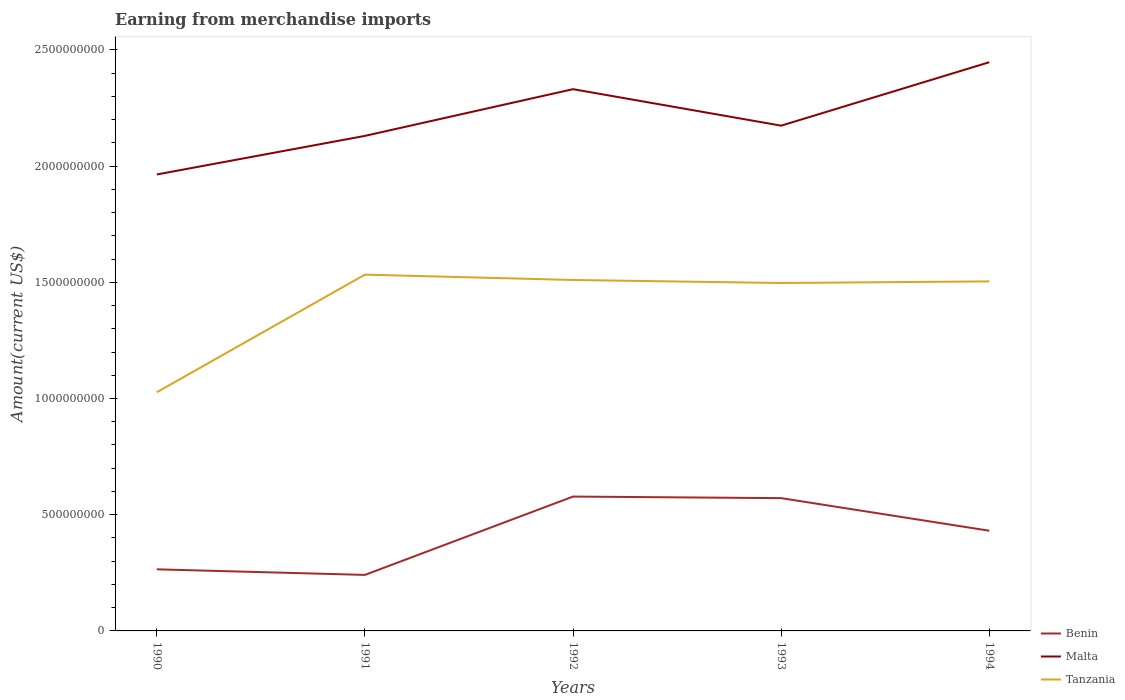How many different coloured lines are there?
Give a very brief answer. 3. Across all years, what is the maximum amount earned from merchandise imports in Benin?
Make the answer very short. 2.41e+08. What is the total amount earned from merchandise imports in Benin in the graph?
Offer a terse response. -3.30e+08. What is the difference between the highest and the second highest amount earned from merchandise imports in Tanzania?
Give a very brief answer. 5.06e+08. Is the amount earned from merchandise imports in Tanzania strictly greater than the amount earned from merchandise imports in Benin over the years?
Your answer should be compact. No. What is the difference between two consecutive major ticks on the Y-axis?
Give a very brief answer. 5.00e+08. Are the values on the major ticks of Y-axis written in scientific E-notation?
Offer a terse response. No. How many legend labels are there?
Make the answer very short. 3. How are the legend labels stacked?
Ensure brevity in your answer.  Vertical. What is the title of the graph?
Give a very brief answer. Earning from merchandise imports. Does "Mauritania" appear as one of the legend labels in the graph?
Your response must be concise. No. What is the label or title of the Y-axis?
Your answer should be very brief. Amount(current US$). What is the Amount(current US$) in Benin in 1990?
Make the answer very short. 2.65e+08. What is the Amount(current US$) in Malta in 1990?
Offer a terse response. 1.96e+09. What is the Amount(current US$) in Tanzania in 1990?
Your answer should be compact. 1.03e+09. What is the Amount(current US$) in Benin in 1991?
Your answer should be compact. 2.41e+08. What is the Amount(current US$) of Malta in 1991?
Your answer should be very brief. 2.13e+09. What is the Amount(current US$) in Tanzania in 1991?
Your answer should be compact. 1.53e+09. What is the Amount(current US$) in Benin in 1992?
Provide a short and direct response. 5.78e+08. What is the Amount(current US$) of Malta in 1992?
Keep it short and to the point. 2.33e+09. What is the Amount(current US$) of Tanzania in 1992?
Give a very brief answer. 1.51e+09. What is the Amount(current US$) of Benin in 1993?
Give a very brief answer. 5.71e+08. What is the Amount(current US$) in Malta in 1993?
Offer a terse response. 2.17e+09. What is the Amount(current US$) in Tanzania in 1993?
Offer a very short reply. 1.50e+09. What is the Amount(current US$) of Benin in 1994?
Ensure brevity in your answer.  4.31e+08. What is the Amount(current US$) of Malta in 1994?
Offer a very short reply. 2.45e+09. What is the Amount(current US$) in Tanzania in 1994?
Keep it short and to the point. 1.50e+09. Across all years, what is the maximum Amount(current US$) in Benin?
Make the answer very short. 5.78e+08. Across all years, what is the maximum Amount(current US$) in Malta?
Your answer should be very brief. 2.45e+09. Across all years, what is the maximum Amount(current US$) in Tanzania?
Provide a short and direct response. 1.53e+09. Across all years, what is the minimum Amount(current US$) in Benin?
Offer a very short reply. 2.41e+08. Across all years, what is the minimum Amount(current US$) in Malta?
Offer a very short reply. 1.96e+09. Across all years, what is the minimum Amount(current US$) of Tanzania?
Ensure brevity in your answer.  1.03e+09. What is the total Amount(current US$) in Benin in the graph?
Your response must be concise. 2.09e+09. What is the total Amount(current US$) in Malta in the graph?
Give a very brief answer. 1.10e+1. What is the total Amount(current US$) of Tanzania in the graph?
Make the answer very short. 7.07e+09. What is the difference between the Amount(current US$) of Benin in 1990 and that in 1991?
Give a very brief answer. 2.40e+07. What is the difference between the Amount(current US$) in Malta in 1990 and that in 1991?
Provide a succinct answer. -1.66e+08. What is the difference between the Amount(current US$) in Tanzania in 1990 and that in 1991?
Your answer should be very brief. -5.06e+08. What is the difference between the Amount(current US$) in Benin in 1990 and that in 1992?
Offer a very short reply. -3.13e+08. What is the difference between the Amount(current US$) of Malta in 1990 and that in 1992?
Give a very brief answer. -3.67e+08. What is the difference between the Amount(current US$) in Tanzania in 1990 and that in 1992?
Keep it short and to the point. -4.83e+08. What is the difference between the Amount(current US$) in Benin in 1990 and that in 1993?
Ensure brevity in your answer.  -3.06e+08. What is the difference between the Amount(current US$) in Malta in 1990 and that in 1993?
Make the answer very short. -2.10e+08. What is the difference between the Amount(current US$) of Tanzania in 1990 and that in 1993?
Keep it short and to the point. -4.70e+08. What is the difference between the Amount(current US$) of Benin in 1990 and that in 1994?
Provide a succinct answer. -1.66e+08. What is the difference between the Amount(current US$) of Malta in 1990 and that in 1994?
Keep it short and to the point. -4.83e+08. What is the difference between the Amount(current US$) of Tanzania in 1990 and that in 1994?
Provide a short and direct response. -4.77e+08. What is the difference between the Amount(current US$) in Benin in 1991 and that in 1992?
Your response must be concise. -3.37e+08. What is the difference between the Amount(current US$) in Malta in 1991 and that in 1992?
Your response must be concise. -2.01e+08. What is the difference between the Amount(current US$) in Tanzania in 1991 and that in 1992?
Offer a terse response. 2.30e+07. What is the difference between the Amount(current US$) of Benin in 1991 and that in 1993?
Keep it short and to the point. -3.30e+08. What is the difference between the Amount(current US$) of Malta in 1991 and that in 1993?
Provide a succinct answer. -4.40e+07. What is the difference between the Amount(current US$) in Tanzania in 1991 and that in 1993?
Offer a terse response. 3.60e+07. What is the difference between the Amount(current US$) of Benin in 1991 and that in 1994?
Ensure brevity in your answer.  -1.90e+08. What is the difference between the Amount(current US$) in Malta in 1991 and that in 1994?
Make the answer very short. -3.17e+08. What is the difference between the Amount(current US$) in Tanzania in 1991 and that in 1994?
Give a very brief answer. 2.90e+07. What is the difference between the Amount(current US$) of Benin in 1992 and that in 1993?
Offer a terse response. 6.78e+06. What is the difference between the Amount(current US$) in Malta in 1992 and that in 1993?
Your answer should be very brief. 1.57e+08. What is the difference between the Amount(current US$) in Tanzania in 1992 and that in 1993?
Provide a succinct answer. 1.30e+07. What is the difference between the Amount(current US$) in Benin in 1992 and that in 1994?
Make the answer very short. 1.47e+08. What is the difference between the Amount(current US$) of Malta in 1992 and that in 1994?
Your answer should be compact. -1.16e+08. What is the difference between the Amount(current US$) in Tanzania in 1992 and that in 1994?
Provide a short and direct response. 6.00e+06. What is the difference between the Amount(current US$) in Benin in 1993 and that in 1994?
Your answer should be very brief. 1.40e+08. What is the difference between the Amount(current US$) of Malta in 1993 and that in 1994?
Provide a succinct answer. -2.73e+08. What is the difference between the Amount(current US$) of Tanzania in 1993 and that in 1994?
Make the answer very short. -7.00e+06. What is the difference between the Amount(current US$) in Benin in 1990 and the Amount(current US$) in Malta in 1991?
Ensure brevity in your answer.  -1.86e+09. What is the difference between the Amount(current US$) of Benin in 1990 and the Amount(current US$) of Tanzania in 1991?
Your answer should be compact. -1.27e+09. What is the difference between the Amount(current US$) of Malta in 1990 and the Amount(current US$) of Tanzania in 1991?
Your response must be concise. 4.31e+08. What is the difference between the Amount(current US$) of Benin in 1990 and the Amount(current US$) of Malta in 1992?
Offer a terse response. -2.07e+09. What is the difference between the Amount(current US$) in Benin in 1990 and the Amount(current US$) in Tanzania in 1992?
Keep it short and to the point. -1.24e+09. What is the difference between the Amount(current US$) in Malta in 1990 and the Amount(current US$) in Tanzania in 1992?
Ensure brevity in your answer.  4.54e+08. What is the difference between the Amount(current US$) in Benin in 1990 and the Amount(current US$) in Malta in 1993?
Provide a succinct answer. -1.91e+09. What is the difference between the Amount(current US$) of Benin in 1990 and the Amount(current US$) of Tanzania in 1993?
Make the answer very short. -1.23e+09. What is the difference between the Amount(current US$) of Malta in 1990 and the Amount(current US$) of Tanzania in 1993?
Give a very brief answer. 4.67e+08. What is the difference between the Amount(current US$) of Benin in 1990 and the Amount(current US$) of Malta in 1994?
Provide a succinct answer. -2.18e+09. What is the difference between the Amount(current US$) in Benin in 1990 and the Amount(current US$) in Tanzania in 1994?
Ensure brevity in your answer.  -1.24e+09. What is the difference between the Amount(current US$) of Malta in 1990 and the Amount(current US$) of Tanzania in 1994?
Your response must be concise. 4.60e+08. What is the difference between the Amount(current US$) of Benin in 1991 and the Amount(current US$) of Malta in 1992?
Provide a succinct answer. -2.09e+09. What is the difference between the Amount(current US$) of Benin in 1991 and the Amount(current US$) of Tanzania in 1992?
Provide a succinct answer. -1.27e+09. What is the difference between the Amount(current US$) of Malta in 1991 and the Amount(current US$) of Tanzania in 1992?
Your response must be concise. 6.20e+08. What is the difference between the Amount(current US$) in Benin in 1991 and the Amount(current US$) in Malta in 1993?
Your answer should be compact. -1.93e+09. What is the difference between the Amount(current US$) in Benin in 1991 and the Amount(current US$) in Tanzania in 1993?
Offer a terse response. -1.26e+09. What is the difference between the Amount(current US$) in Malta in 1991 and the Amount(current US$) in Tanzania in 1993?
Offer a very short reply. 6.33e+08. What is the difference between the Amount(current US$) of Benin in 1991 and the Amount(current US$) of Malta in 1994?
Provide a short and direct response. -2.21e+09. What is the difference between the Amount(current US$) in Benin in 1991 and the Amount(current US$) in Tanzania in 1994?
Your answer should be very brief. -1.26e+09. What is the difference between the Amount(current US$) in Malta in 1991 and the Amount(current US$) in Tanzania in 1994?
Offer a very short reply. 6.26e+08. What is the difference between the Amount(current US$) in Benin in 1992 and the Amount(current US$) in Malta in 1993?
Provide a succinct answer. -1.60e+09. What is the difference between the Amount(current US$) of Benin in 1992 and the Amount(current US$) of Tanzania in 1993?
Offer a terse response. -9.19e+08. What is the difference between the Amount(current US$) of Malta in 1992 and the Amount(current US$) of Tanzania in 1993?
Keep it short and to the point. 8.34e+08. What is the difference between the Amount(current US$) in Benin in 1992 and the Amount(current US$) in Malta in 1994?
Keep it short and to the point. -1.87e+09. What is the difference between the Amount(current US$) of Benin in 1992 and the Amount(current US$) of Tanzania in 1994?
Offer a very short reply. -9.26e+08. What is the difference between the Amount(current US$) in Malta in 1992 and the Amount(current US$) in Tanzania in 1994?
Offer a very short reply. 8.27e+08. What is the difference between the Amount(current US$) in Benin in 1993 and the Amount(current US$) in Malta in 1994?
Offer a terse response. -1.88e+09. What is the difference between the Amount(current US$) of Benin in 1993 and the Amount(current US$) of Tanzania in 1994?
Your answer should be very brief. -9.33e+08. What is the difference between the Amount(current US$) of Malta in 1993 and the Amount(current US$) of Tanzania in 1994?
Offer a very short reply. 6.70e+08. What is the average Amount(current US$) in Benin per year?
Give a very brief answer. 4.17e+08. What is the average Amount(current US$) in Malta per year?
Offer a terse response. 2.21e+09. What is the average Amount(current US$) of Tanzania per year?
Your response must be concise. 1.41e+09. In the year 1990, what is the difference between the Amount(current US$) in Benin and Amount(current US$) in Malta?
Your answer should be compact. -1.70e+09. In the year 1990, what is the difference between the Amount(current US$) of Benin and Amount(current US$) of Tanzania?
Your response must be concise. -7.62e+08. In the year 1990, what is the difference between the Amount(current US$) of Malta and Amount(current US$) of Tanzania?
Provide a short and direct response. 9.37e+08. In the year 1991, what is the difference between the Amount(current US$) of Benin and Amount(current US$) of Malta?
Your response must be concise. -1.89e+09. In the year 1991, what is the difference between the Amount(current US$) of Benin and Amount(current US$) of Tanzania?
Your answer should be compact. -1.29e+09. In the year 1991, what is the difference between the Amount(current US$) in Malta and Amount(current US$) in Tanzania?
Provide a short and direct response. 5.97e+08. In the year 1992, what is the difference between the Amount(current US$) of Benin and Amount(current US$) of Malta?
Provide a succinct answer. -1.75e+09. In the year 1992, what is the difference between the Amount(current US$) in Benin and Amount(current US$) in Tanzania?
Your answer should be very brief. -9.32e+08. In the year 1992, what is the difference between the Amount(current US$) of Malta and Amount(current US$) of Tanzania?
Give a very brief answer. 8.21e+08. In the year 1993, what is the difference between the Amount(current US$) in Benin and Amount(current US$) in Malta?
Offer a terse response. -1.60e+09. In the year 1993, what is the difference between the Amount(current US$) in Benin and Amount(current US$) in Tanzania?
Ensure brevity in your answer.  -9.26e+08. In the year 1993, what is the difference between the Amount(current US$) in Malta and Amount(current US$) in Tanzania?
Your answer should be very brief. 6.77e+08. In the year 1994, what is the difference between the Amount(current US$) of Benin and Amount(current US$) of Malta?
Offer a very short reply. -2.02e+09. In the year 1994, what is the difference between the Amount(current US$) in Benin and Amount(current US$) in Tanzania?
Give a very brief answer. -1.07e+09. In the year 1994, what is the difference between the Amount(current US$) in Malta and Amount(current US$) in Tanzania?
Your response must be concise. 9.43e+08. What is the ratio of the Amount(current US$) in Benin in 1990 to that in 1991?
Your response must be concise. 1.1. What is the ratio of the Amount(current US$) in Malta in 1990 to that in 1991?
Ensure brevity in your answer.  0.92. What is the ratio of the Amount(current US$) in Tanzania in 1990 to that in 1991?
Give a very brief answer. 0.67. What is the ratio of the Amount(current US$) in Benin in 1990 to that in 1992?
Provide a short and direct response. 0.46. What is the ratio of the Amount(current US$) in Malta in 1990 to that in 1992?
Offer a terse response. 0.84. What is the ratio of the Amount(current US$) in Tanzania in 1990 to that in 1992?
Provide a short and direct response. 0.68. What is the ratio of the Amount(current US$) of Benin in 1990 to that in 1993?
Your response must be concise. 0.46. What is the ratio of the Amount(current US$) of Malta in 1990 to that in 1993?
Your response must be concise. 0.9. What is the ratio of the Amount(current US$) of Tanzania in 1990 to that in 1993?
Your answer should be compact. 0.69. What is the ratio of the Amount(current US$) of Benin in 1990 to that in 1994?
Give a very brief answer. 0.61. What is the ratio of the Amount(current US$) in Malta in 1990 to that in 1994?
Your response must be concise. 0.8. What is the ratio of the Amount(current US$) in Tanzania in 1990 to that in 1994?
Keep it short and to the point. 0.68. What is the ratio of the Amount(current US$) of Benin in 1991 to that in 1992?
Offer a very short reply. 0.42. What is the ratio of the Amount(current US$) of Malta in 1991 to that in 1992?
Your response must be concise. 0.91. What is the ratio of the Amount(current US$) of Tanzania in 1991 to that in 1992?
Provide a short and direct response. 1.02. What is the ratio of the Amount(current US$) in Benin in 1991 to that in 1993?
Your answer should be very brief. 0.42. What is the ratio of the Amount(current US$) of Malta in 1991 to that in 1993?
Your response must be concise. 0.98. What is the ratio of the Amount(current US$) of Benin in 1991 to that in 1994?
Your answer should be very brief. 0.56. What is the ratio of the Amount(current US$) of Malta in 1991 to that in 1994?
Offer a very short reply. 0.87. What is the ratio of the Amount(current US$) of Tanzania in 1991 to that in 1994?
Keep it short and to the point. 1.02. What is the ratio of the Amount(current US$) of Benin in 1992 to that in 1993?
Make the answer very short. 1.01. What is the ratio of the Amount(current US$) of Malta in 1992 to that in 1993?
Offer a very short reply. 1.07. What is the ratio of the Amount(current US$) in Tanzania in 1992 to that in 1993?
Your answer should be very brief. 1.01. What is the ratio of the Amount(current US$) of Benin in 1992 to that in 1994?
Your answer should be very brief. 1.34. What is the ratio of the Amount(current US$) of Malta in 1992 to that in 1994?
Provide a short and direct response. 0.95. What is the ratio of the Amount(current US$) in Tanzania in 1992 to that in 1994?
Offer a terse response. 1. What is the ratio of the Amount(current US$) of Benin in 1993 to that in 1994?
Provide a succinct answer. 1.33. What is the ratio of the Amount(current US$) in Malta in 1993 to that in 1994?
Ensure brevity in your answer.  0.89. What is the ratio of the Amount(current US$) of Tanzania in 1993 to that in 1994?
Keep it short and to the point. 1. What is the difference between the highest and the second highest Amount(current US$) in Benin?
Keep it short and to the point. 6.78e+06. What is the difference between the highest and the second highest Amount(current US$) of Malta?
Keep it short and to the point. 1.16e+08. What is the difference between the highest and the second highest Amount(current US$) of Tanzania?
Your answer should be very brief. 2.30e+07. What is the difference between the highest and the lowest Amount(current US$) of Benin?
Make the answer very short. 3.37e+08. What is the difference between the highest and the lowest Amount(current US$) of Malta?
Offer a terse response. 4.83e+08. What is the difference between the highest and the lowest Amount(current US$) of Tanzania?
Offer a very short reply. 5.06e+08. 